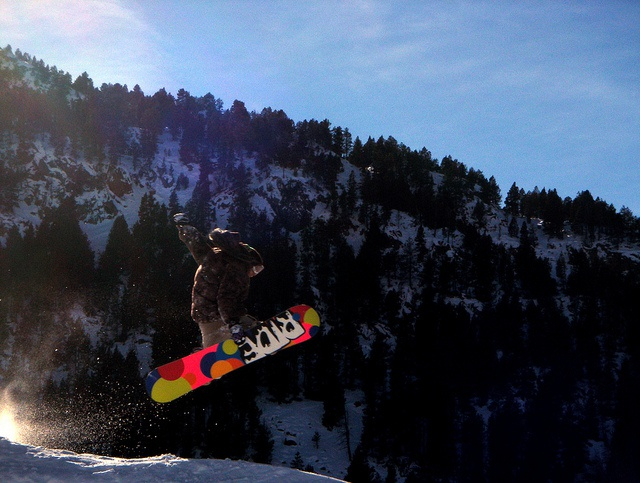Describe the objects in this image and their specific colors. I can see people in pink, black, maroon, and gray tones and snowboard in pink, black, darkgray, olive, and brown tones in this image. 